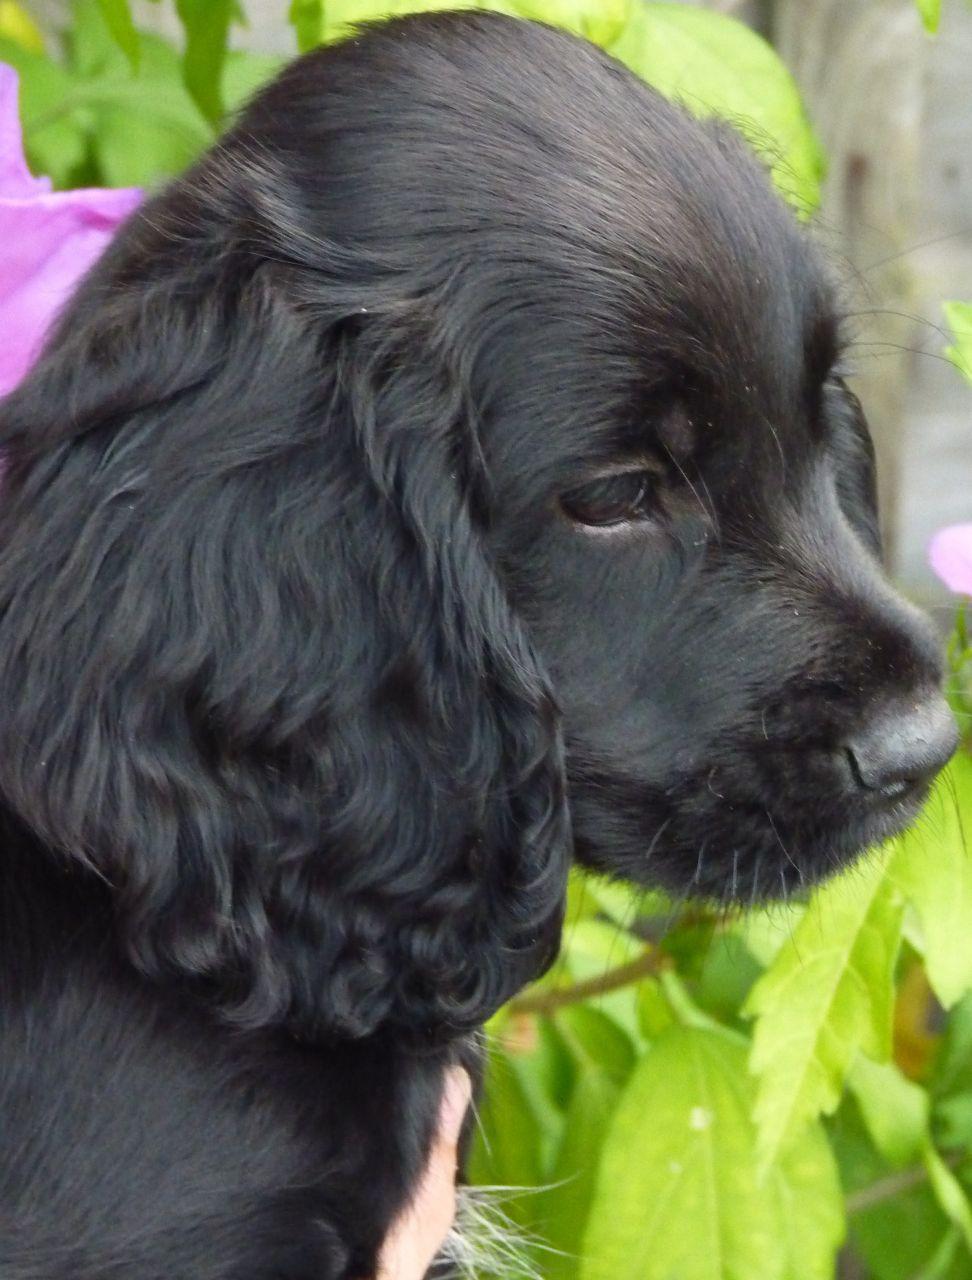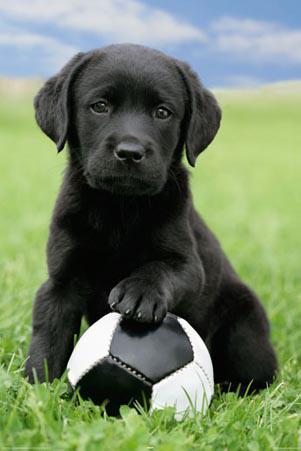The first image is the image on the left, the second image is the image on the right. Given the left and right images, does the statement "An image shows a black-faced dog posed on green grass, touching some type of toy in front of it." hold true? Answer yes or no. Yes. 